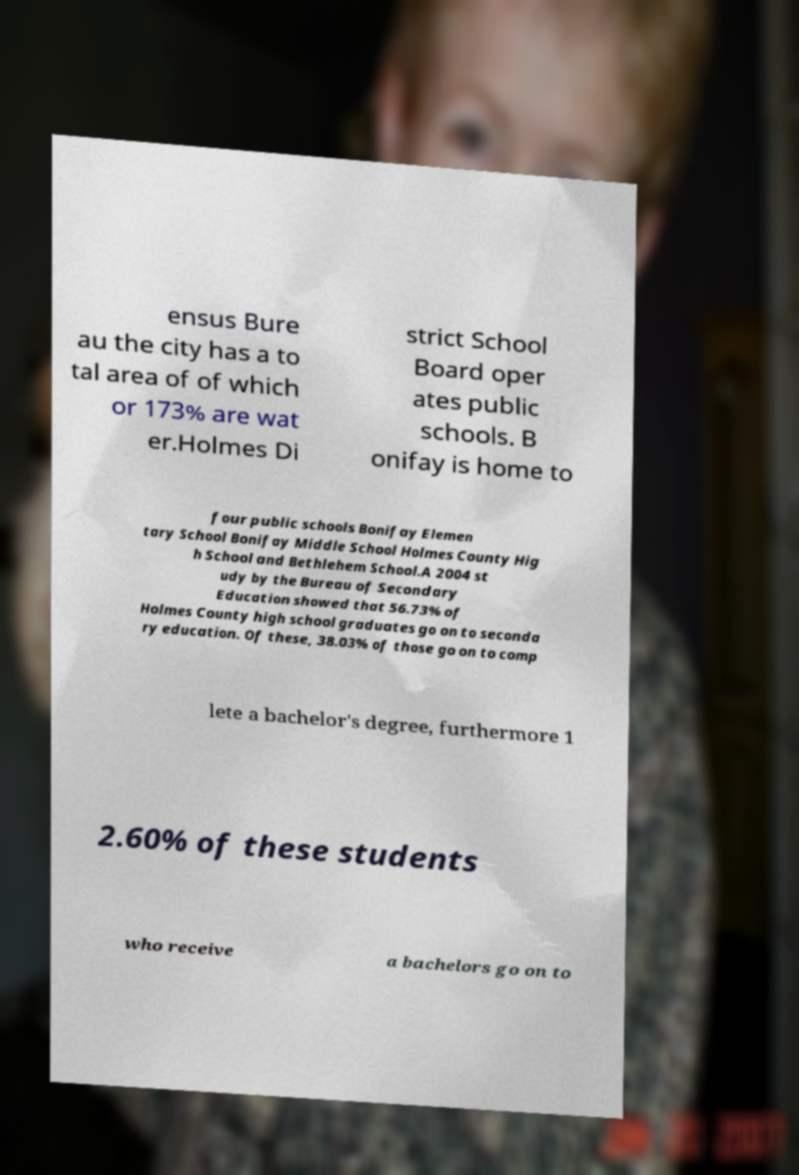For documentation purposes, I need the text within this image transcribed. Could you provide that? ensus Bure au the city has a to tal area of of which or 173% are wat er.Holmes Di strict School Board oper ates public schools. B onifay is home to four public schools Bonifay Elemen tary School Bonifay Middle School Holmes County Hig h School and Bethlehem School.A 2004 st udy by the Bureau of Secondary Education showed that 56.73% of Holmes County high school graduates go on to seconda ry education. Of these, 38.03% of those go on to comp lete a bachelor's degree, furthermore 1 2.60% of these students who receive a bachelors go on to 